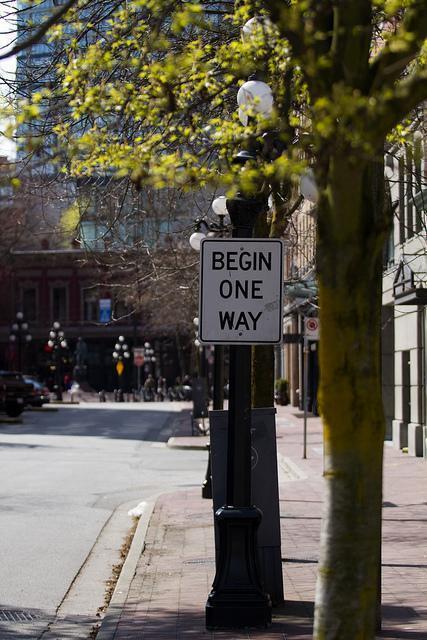What type of road is behind the person who took this picture?
Choose the right answer from the provided options to respond to the question.
Options: Two way, one way, on ramp, none. Two way. 